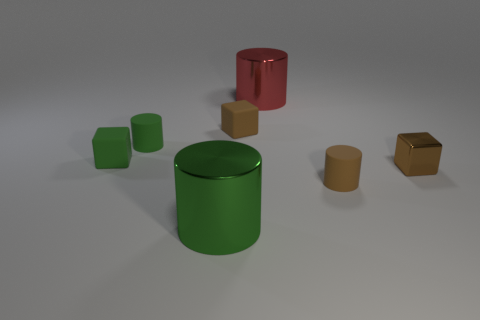There is a green metallic cylinder that is in front of the brown object that is behind the small brown metallic cube; what size is it?
Your answer should be very brief. Large. How many cylinders are either small metallic objects or small rubber objects?
Ensure brevity in your answer.  2. What is the color of the other rubber block that is the same size as the green rubber block?
Offer a very short reply. Brown. There is a tiny brown object on the left side of the small cylinder that is on the right side of the tiny green cylinder; what shape is it?
Your answer should be compact. Cube. There is a matte thing on the right side of the red metallic object; does it have the same size as the green matte cube?
Make the answer very short. Yes. How many other things are there of the same material as the big green cylinder?
Your answer should be compact. 2. How many green objects are either metal things or small matte blocks?
Your answer should be compact. 2. What size is the rubber cylinder that is the same color as the metal block?
Ensure brevity in your answer.  Small. How many tiny brown objects are on the left side of the tiny brown rubber cylinder?
Provide a short and direct response. 1. What size is the cylinder in front of the tiny matte cylinder that is right of the rubber cylinder to the left of the red thing?
Provide a short and direct response. Large. 